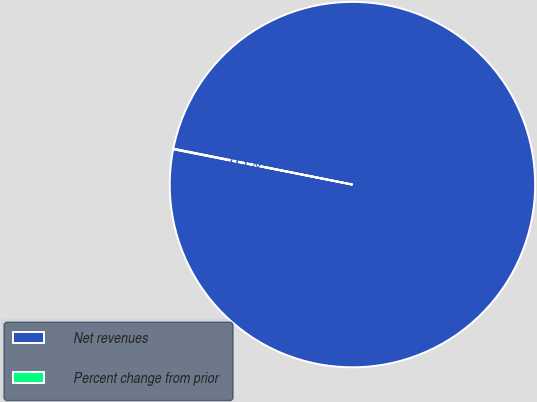<chart> <loc_0><loc_0><loc_500><loc_500><pie_chart><fcel>Net revenues<fcel>Percent change from prior<nl><fcel>99.95%<fcel>0.05%<nl></chart> 